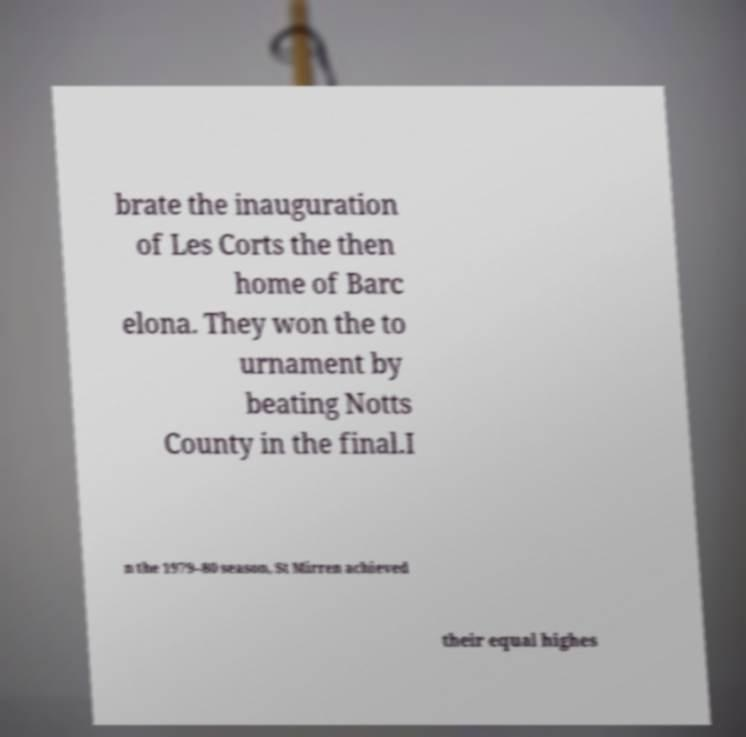Could you extract and type out the text from this image? brate the inauguration of Les Corts the then home of Barc elona. They won the to urnament by beating Notts County in the final.I n the 1979–80 season, St Mirren achieved their equal highes 